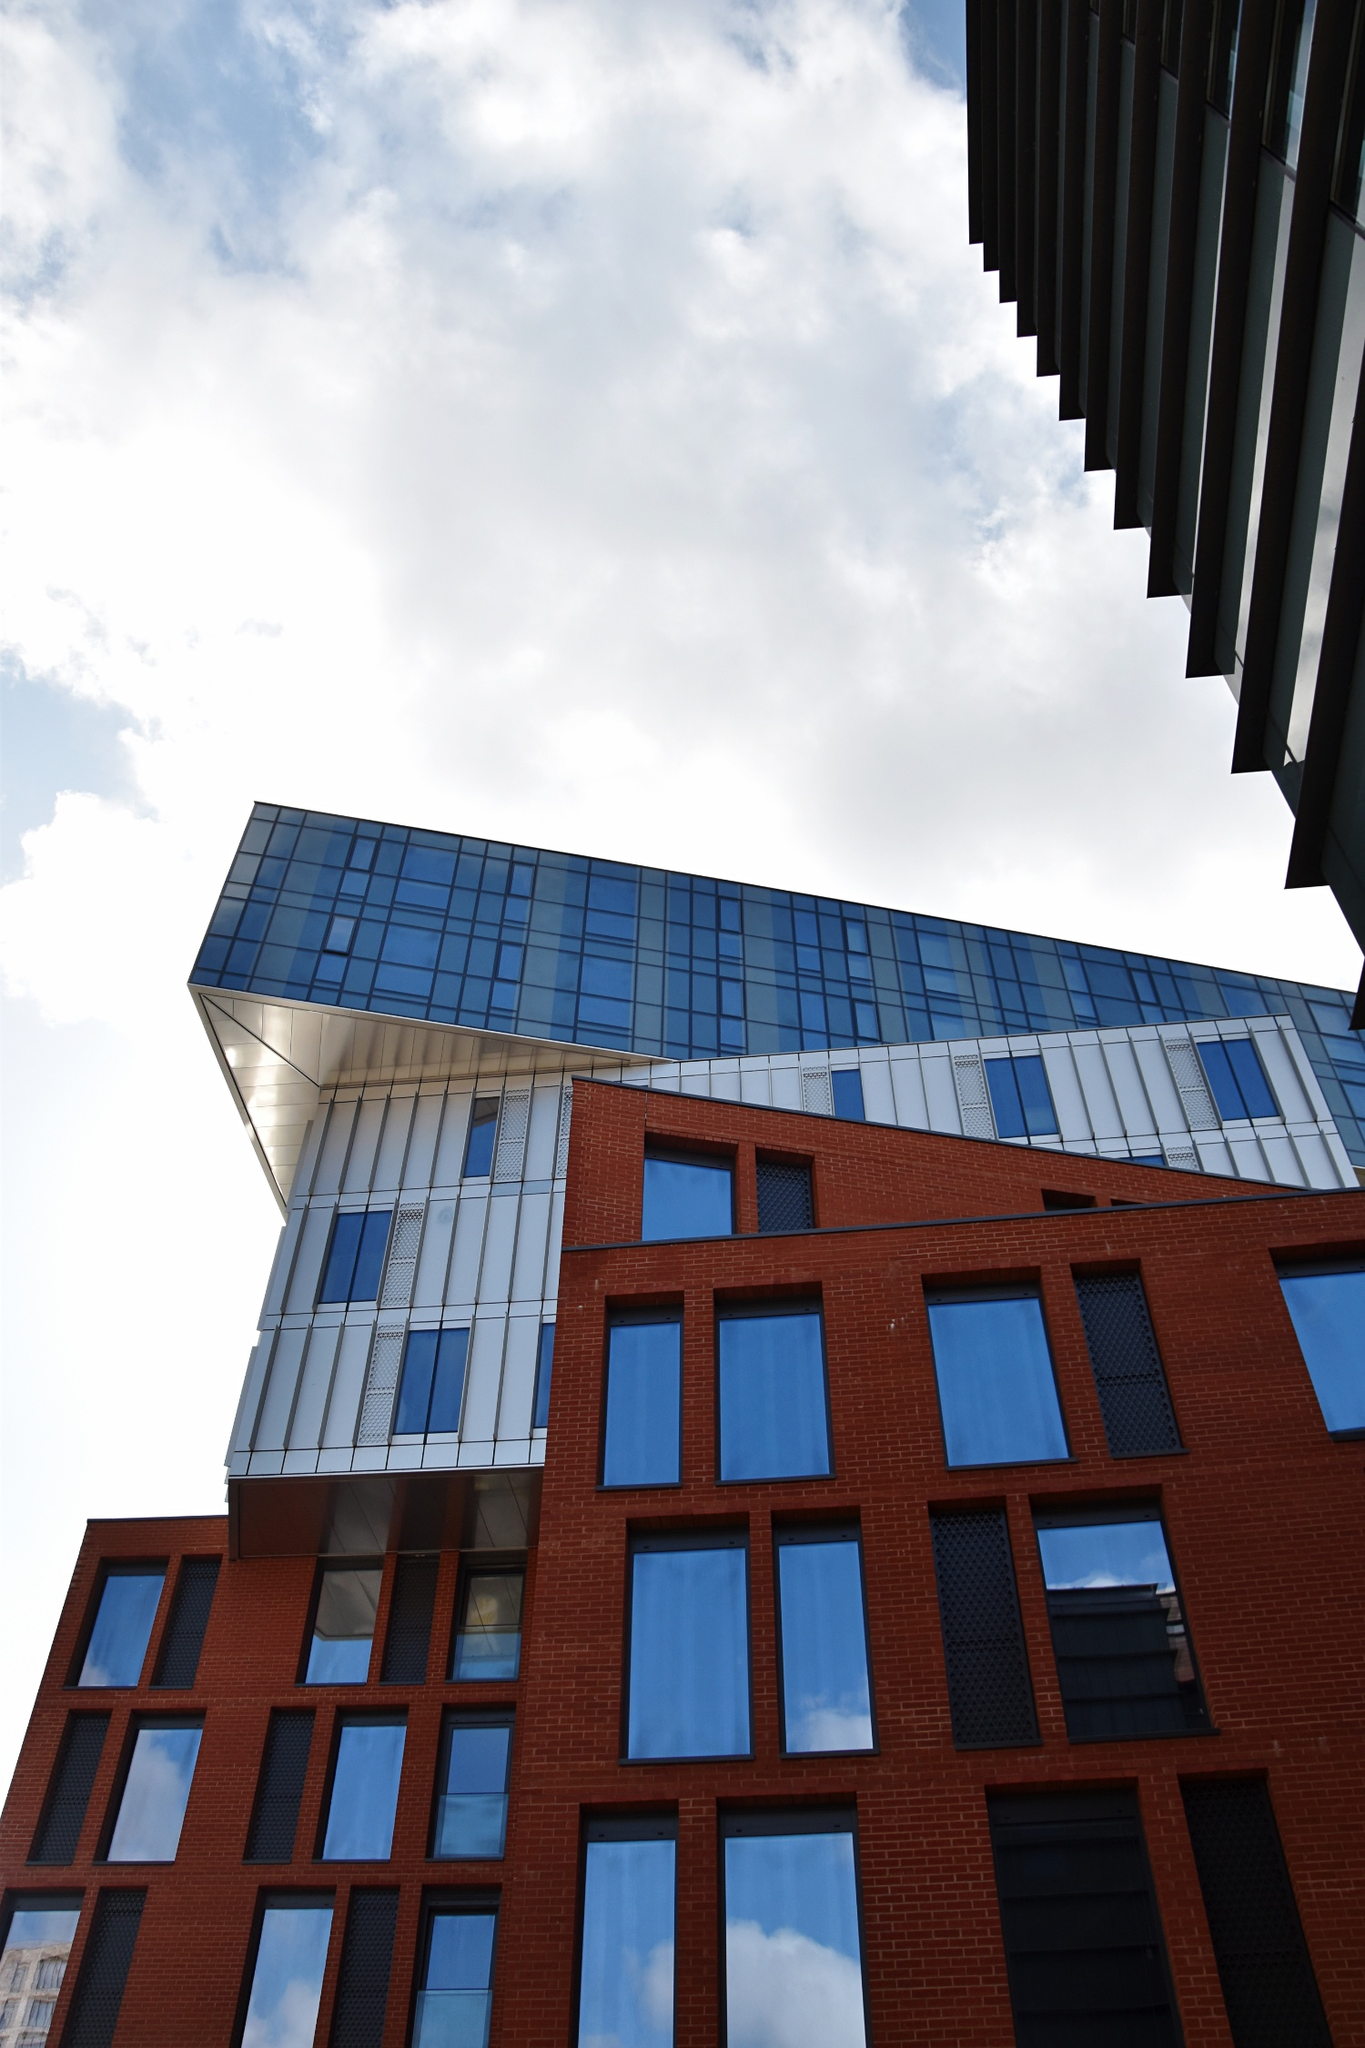Imagine you are an artist tasked with drawing inspiration from this building. What elements would you focus on for your artwork? As an artist drawing inspiration from this building, I would focus on several key elements. The contrast between the red brick and blue-tinted glass would be a central theme, highlighting the interplay between tradition and modernity. The geometric forms, particularly the grid-like windows and the angular glass tower, would provide a framework for exploration of shapes and patterns. The way the building interacts with light, reflecting the sky and casting shadows, would be another focal point, capturing the changing moods of the day. Finally, the perspective from which the photo is taken, emphasizing the building's height and dynamic silhouette, would inspire a composition that celebrates the building’s grandeur and innovative design. Great! Could you create a visual description of a day in the life of this building? Sure! As dawn breaks, the building starts its day bathed in the soft, golden hues of the early morning sun. The red brick facade glows warmly, while the blue-tinted glass reflects the pastel sky, creating a serene and harmonious scene. As the city awakens, people begin to bustling around the area, their reflections darting in and out of the glass windows, adding movement and life to the static structure.

By midday, the sun is at its peak, and the building stands in stark contrast to the bright blue sky. The glass tower shines brilliantly, mirrors the urban landscape surrounding it, and the red brick appears vibrant and strong. The building provides a cool refuge from the heat, its design allowing for both aesthetic appeal and practical comfort.

As the afternoon progresses, shadows begin to lengthen, and the building’s dynamic angles cast dramatic patterns on the ground, creating a play of light and dark. Inside, the blue-tinted windows filter the sunlight, casting calming blue shadows and maintaining a pleasant interior environment.

As dusk approaches, the building takes on a new character; the setting sun casts a warm, orange glow, and the glass tower starts reflecting the vibrant colors of the sunset. The red brick facade deepens in color, and the dynamic silhouette of the building becomes more pronounced against the twilight sky.

Finally, as night falls, the interior lights of the building come to life, turning the glass windows into a mosaic of glowing squares. The building stands as a beacon in the night, its presence both comforting and striking, a modern marvel in an ever-evolving cityscape. 